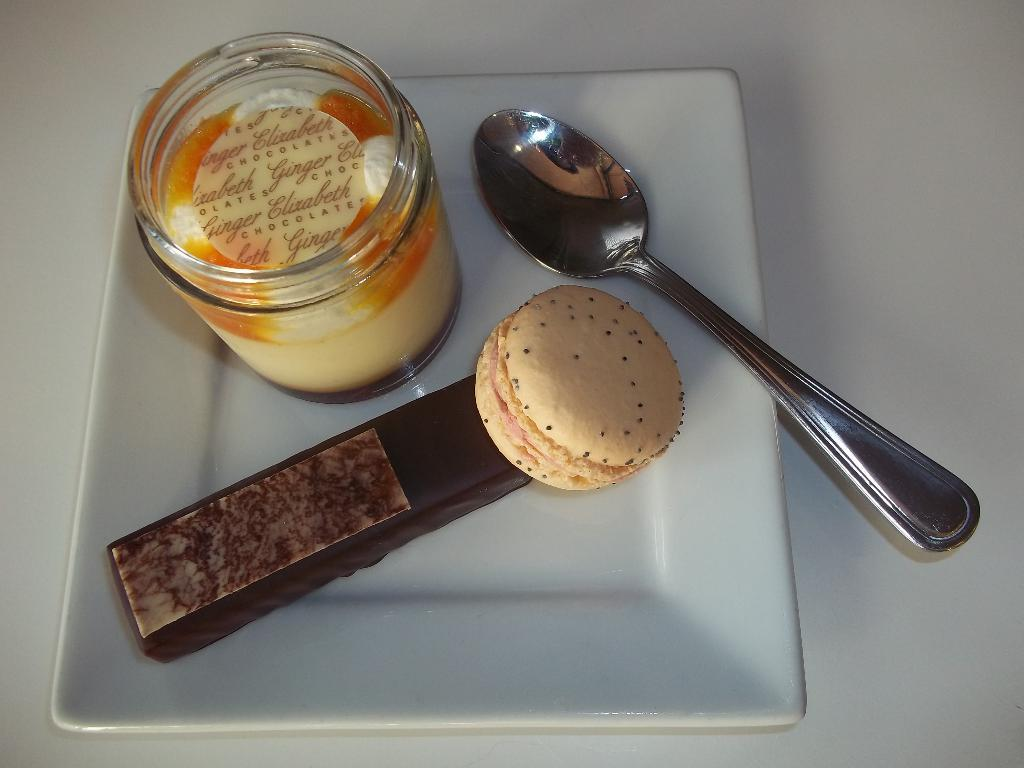What types of food items can be seen in the image? There are food items in the image, but their specific types are not mentioned. What container is present in the image? There is a jar in the image. What utensil is visible in the image? There is a spoon in the image. What is the food placed on in the image? There is a plate in the image. What is the plate resting on in the image? The plate is on an object, but the specific type of object is not mentioned. How much payment is required to purchase the bag in the image? There is no bag present in the image, so the question of payment is not applicable. 